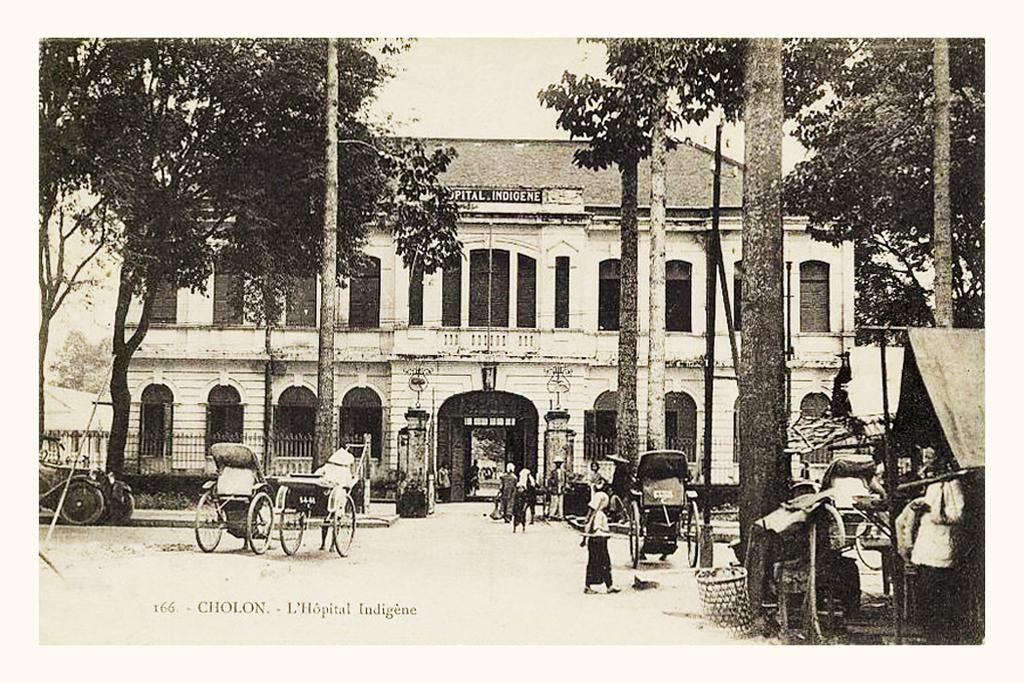What type of image is being described? The image is an old picture. What can be seen in the image besides the old picture? There is a building, persons walking on the road, a tent on the right side, the sky, poles, trees, and vehicles in the image. What type of waves can be seen crashing on the shore in the image? There are no waves or shore present in the image; it features a building, persons walking, a tent, the sky, poles, trees, and vehicles. 